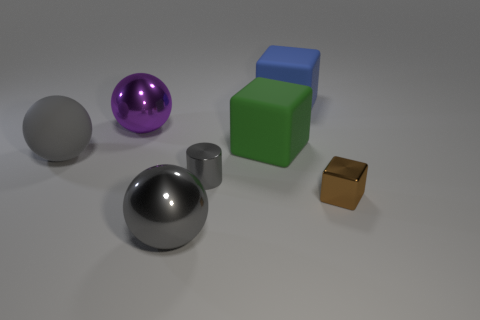Subtract all big green rubber cubes. How many cubes are left? 2 Subtract all blue cubes. How many cubes are left? 2 Add 1 green objects. How many objects exist? 8 Subtract all cylinders. How many objects are left? 6 Subtract 2 blocks. How many blocks are left? 1 Subtract all green balls. Subtract all green blocks. How many balls are left? 3 Subtract all cyan blocks. How many gray spheres are left? 2 Subtract all yellow objects. Subtract all rubber blocks. How many objects are left? 5 Add 7 small things. How many small things are left? 9 Add 3 big objects. How many big objects exist? 8 